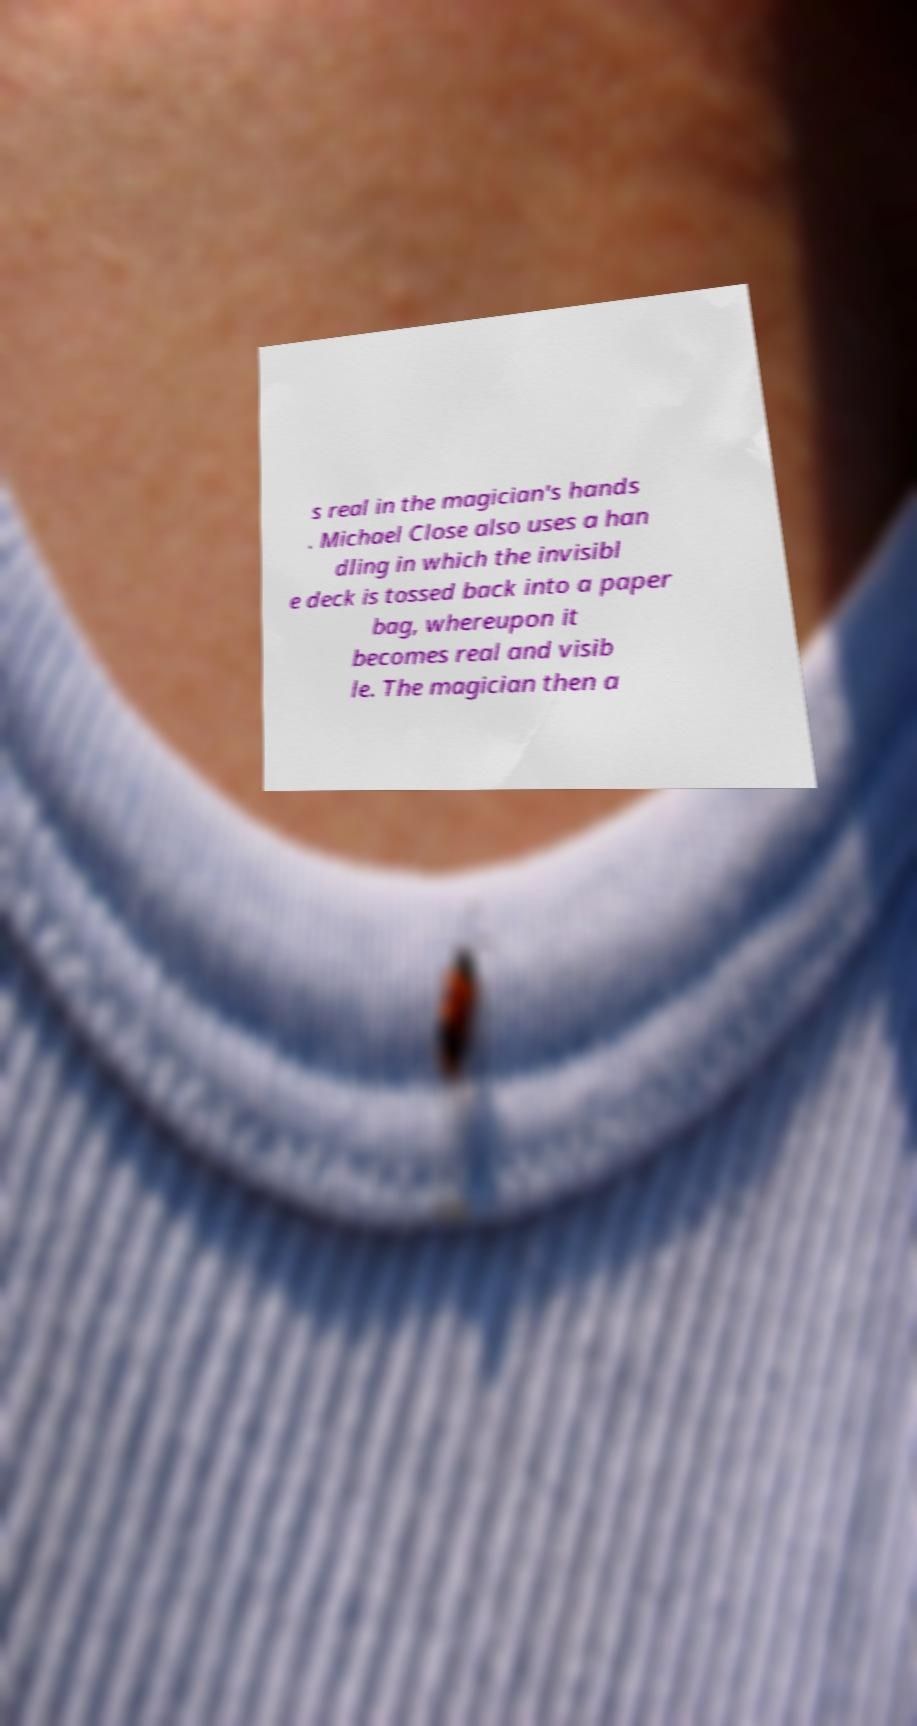There's text embedded in this image that I need extracted. Can you transcribe it verbatim? s real in the magician's hands . Michael Close also uses a han dling in which the invisibl e deck is tossed back into a paper bag, whereupon it becomes real and visib le. The magician then a 